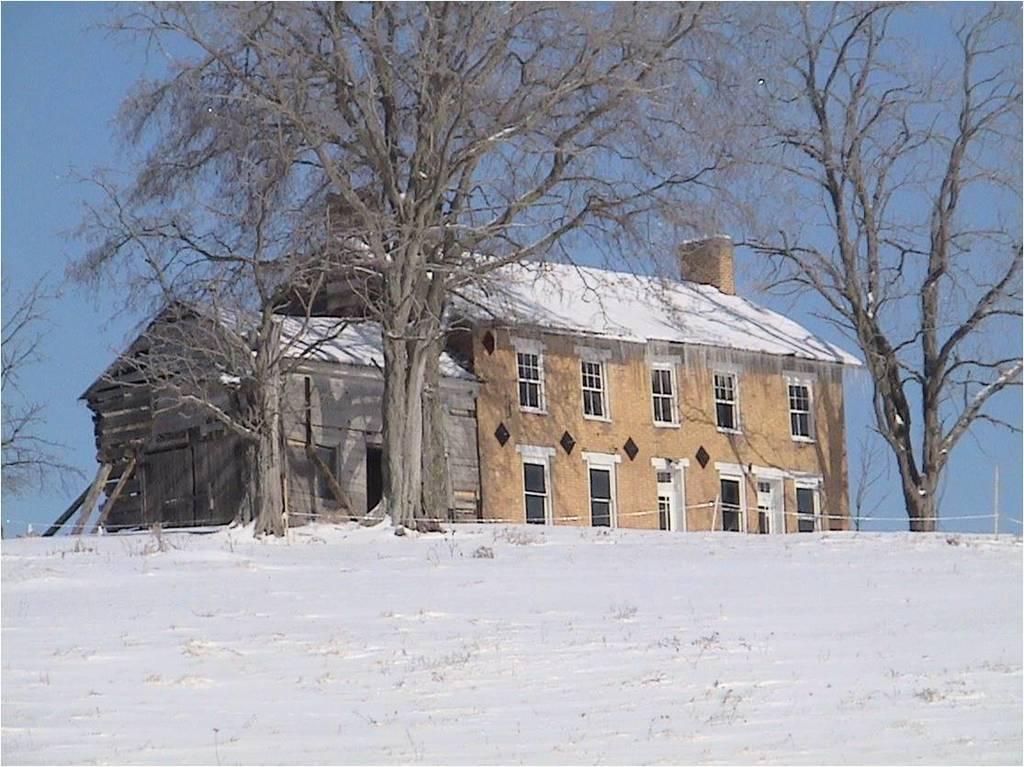How would you summarize this image in a sentence or two? In this image we can see the houses with roof and windows. We can also see a group of trees, some poles with wires, the wooden poles and the sky which looks cloudy. 